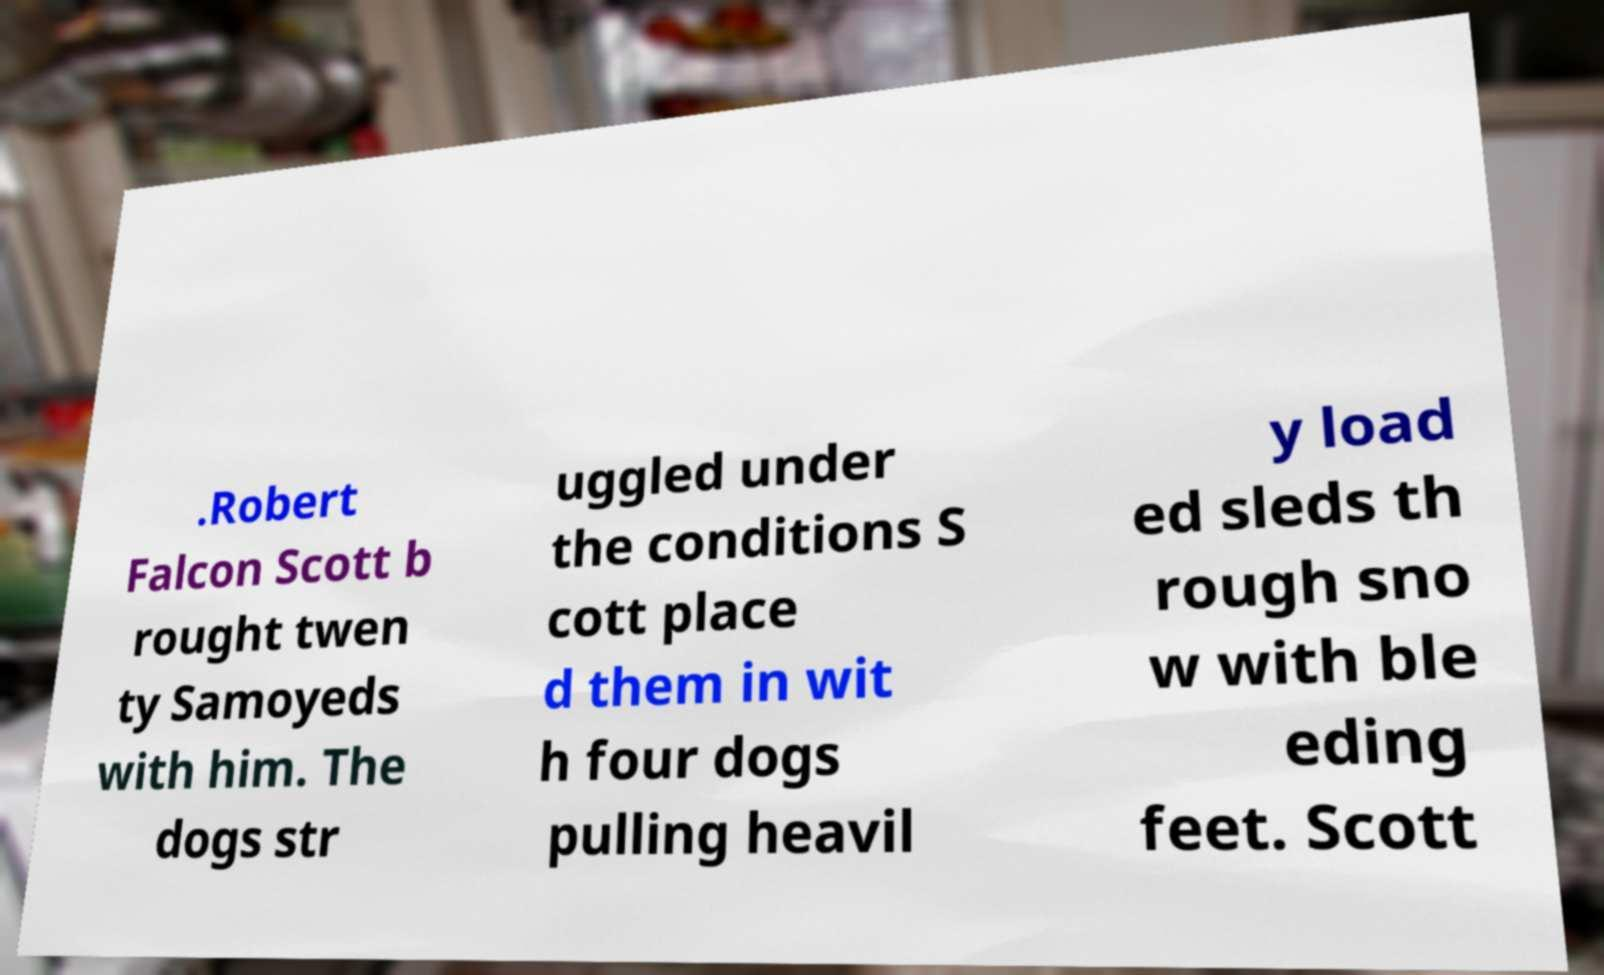There's text embedded in this image that I need extracted. Can you transcribe it verbatim? .Robert Falcon Scott b rought twen ty Samoyeds with him. The dogs str uggled under the conditions S cott place d them in wit h four dogs pulling heavil y load ed sleds th rough sno w with ble eding feet. Scott 